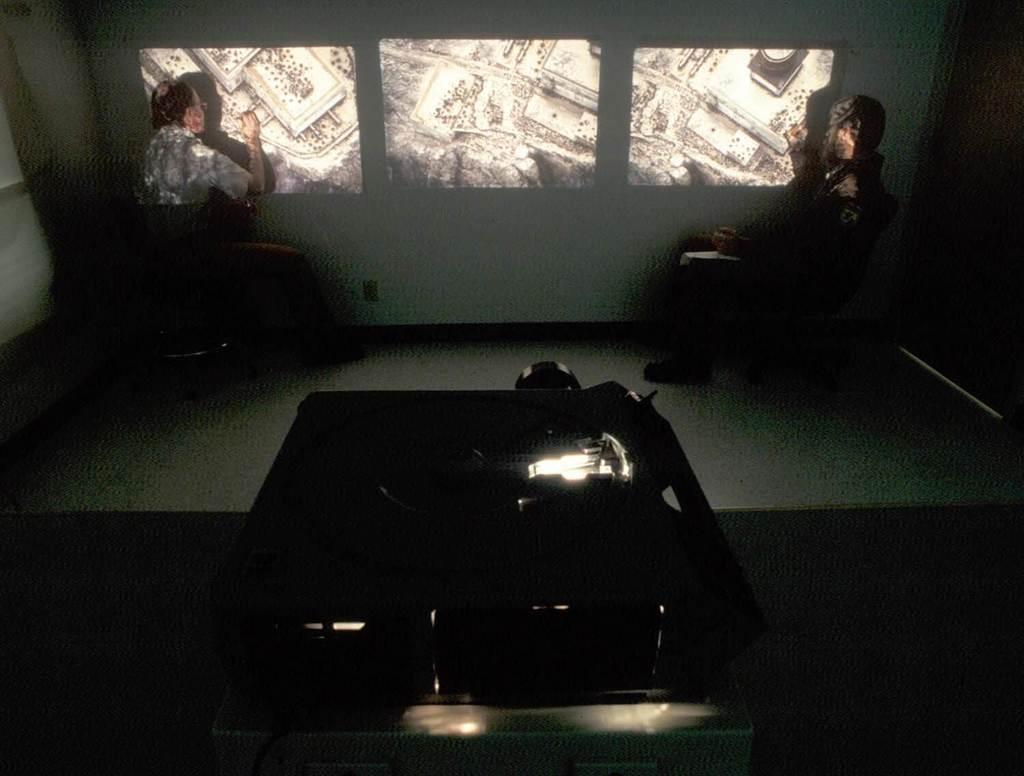What is the main object in the image? There is a projector in the image. Can you describe the people in the image? There are two persons sitting in the back of the image. What is on the wall in the image? There is a wall with images in the image. Where is the bomb hidden in the image? There is no bomb present in the image. Can you see a squirrel running across the wall in the image? There is no squirrel present in the image. 